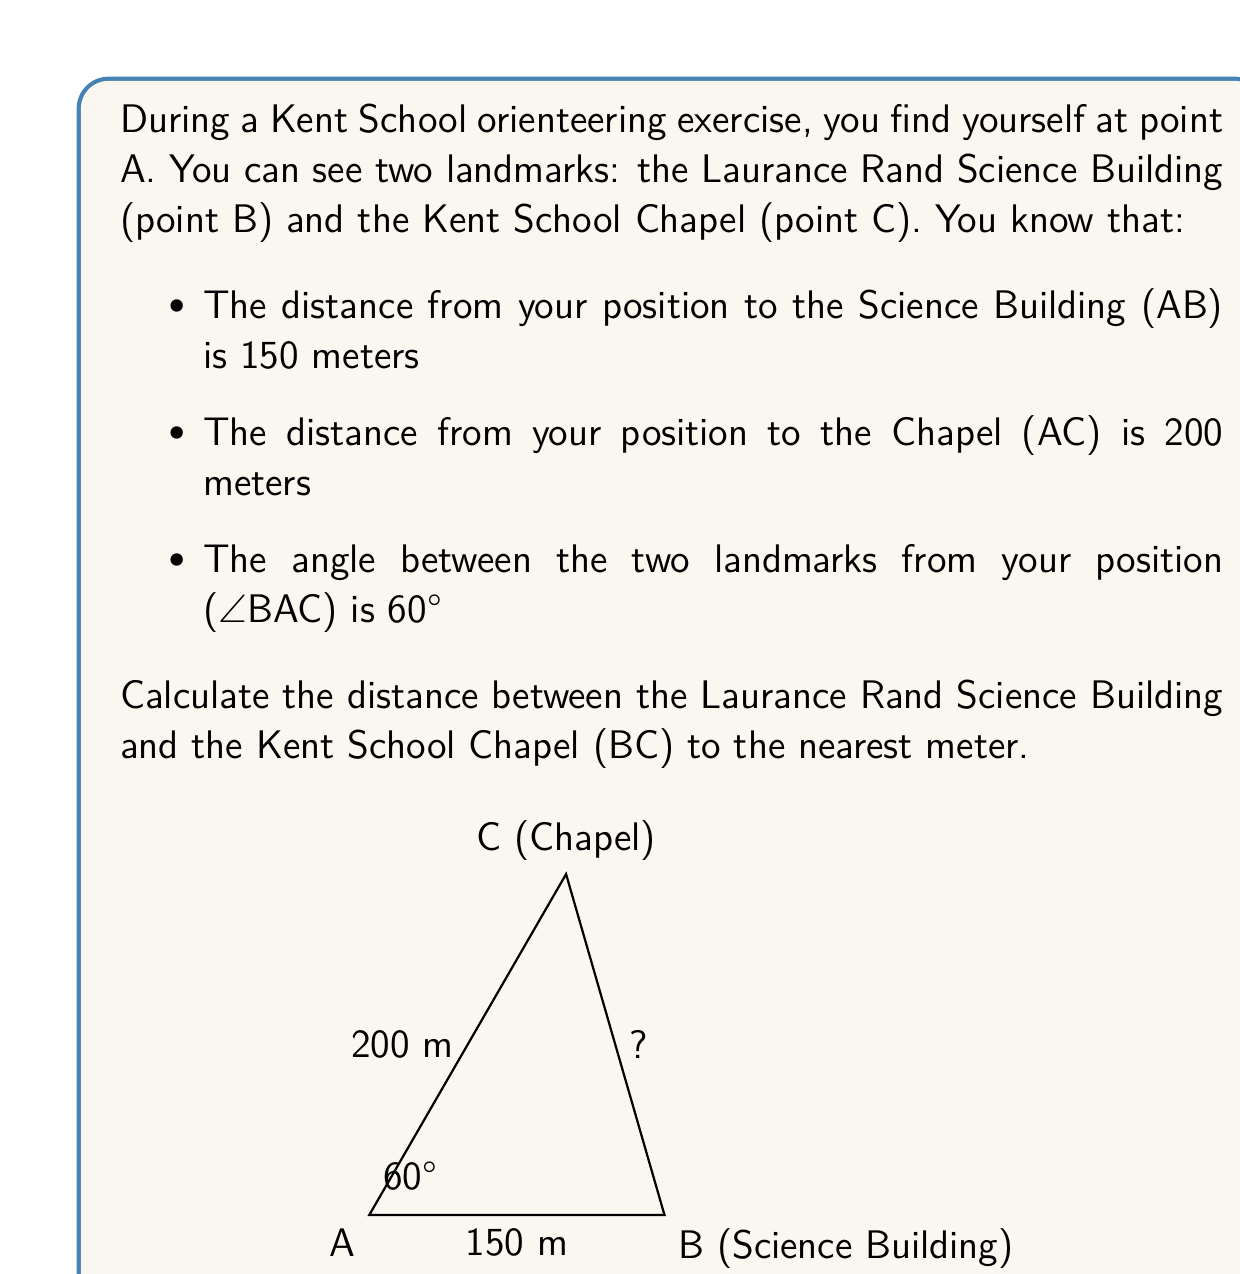Solve this math problem. To solve this problem, we'll use the law of cosines. The law of cosines states that for a triangle with sides a, b, and c, and an angle C opposite side c:

$$c^2 = a^2 + b^2 - 2ab \cos(C)$$

In our case:
- a = AB = 150 m
- b = AC = 200 m
- C = ∠BAC = 60°
- c = BC (the side we're trying to find)

Let's substitute these values into the formula:

$$c^2 = 150^2 + 200^2 - 2(150)(200) \cos(60°)$$

Now, let's solve step by step:

1) First, calculate the known values:
   $$c^2 = 22500 + 40000 - 2(30000) \cos(60°)$$

2) Recall that $\cos(60°) = \frac{1}{2}$:
   $$c^2 = 22500 + 40000 - 2(30000) (\frac{1}{2})$$

3) Simplify:
   $$c^2 = 22500 + 40000 - 30000$$
   $$c^2 = 32500$$

4) Take the square root of both sides:
   $$c = \sqrt{32500}$$

5) Calculate and round to the nearest meter:
   $$c \approx 180.28 \text{ m} \approx 180 \text{ m}$$

Therefore, the distance between the Laurance Rand Science Building and the Kent School Chapel is approximately 180 meters.
Answer: 180 meters 